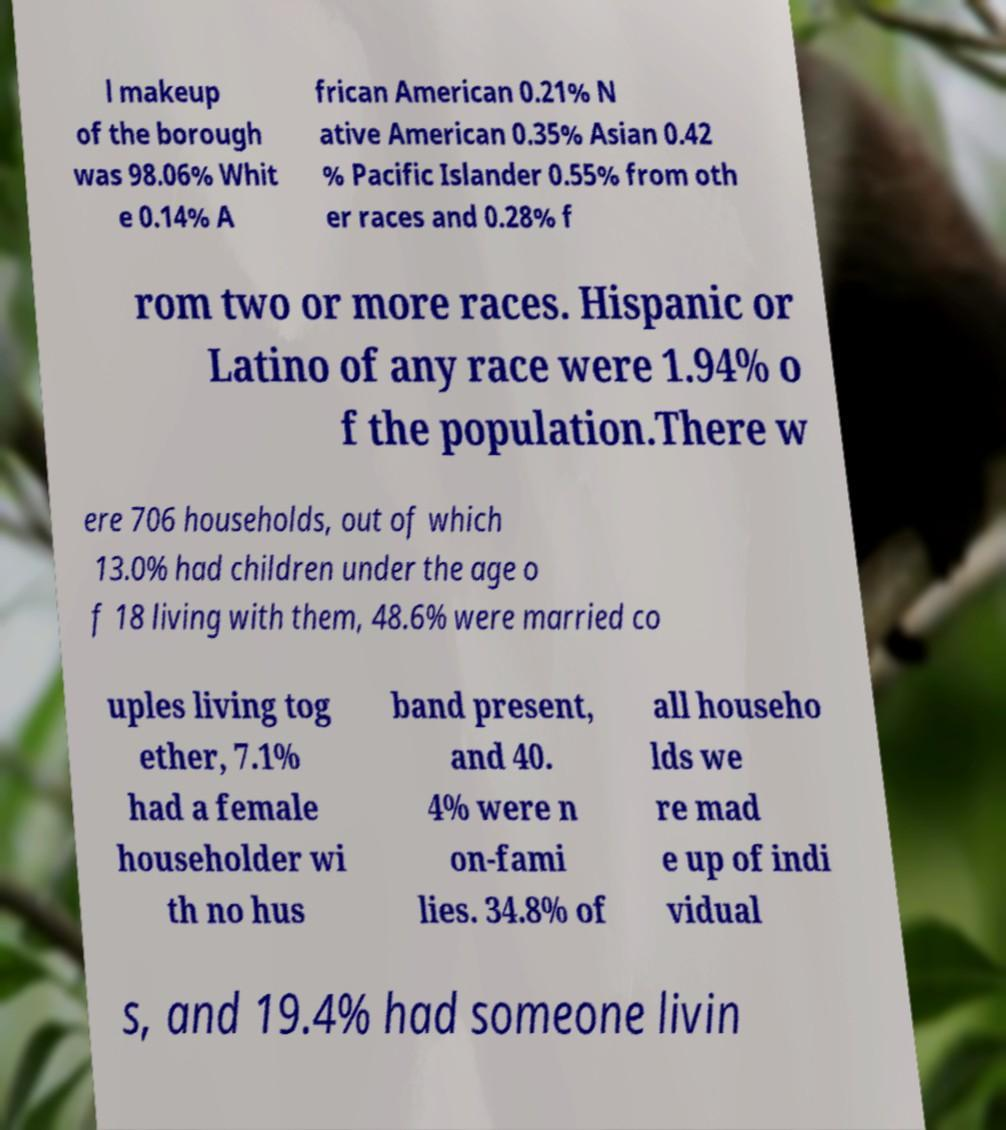For documentation purposes, I need the text within this image transcribed. Could you provide that? l makeup of the borough was 98.06% Whit e 0.14% A frican American 0.21% N ative American 0.35% Asian 0.42 % Pacific Islander 0.55% from oth er races and 0.28% f rom two or more races. Hispanic or Latino of any race were 1.94% o f the population.There w ere 706 households, out of which 13.0% had children under the age o f 18 living with them, 48.6% were married co uples living tog ether, 7.1% had a female householder wi th no hus band present, and 40. 4% were n on-fami lies. 34.8% of all househo lds we re mad e up of indi vidual s, and 19.4% had someone livin 